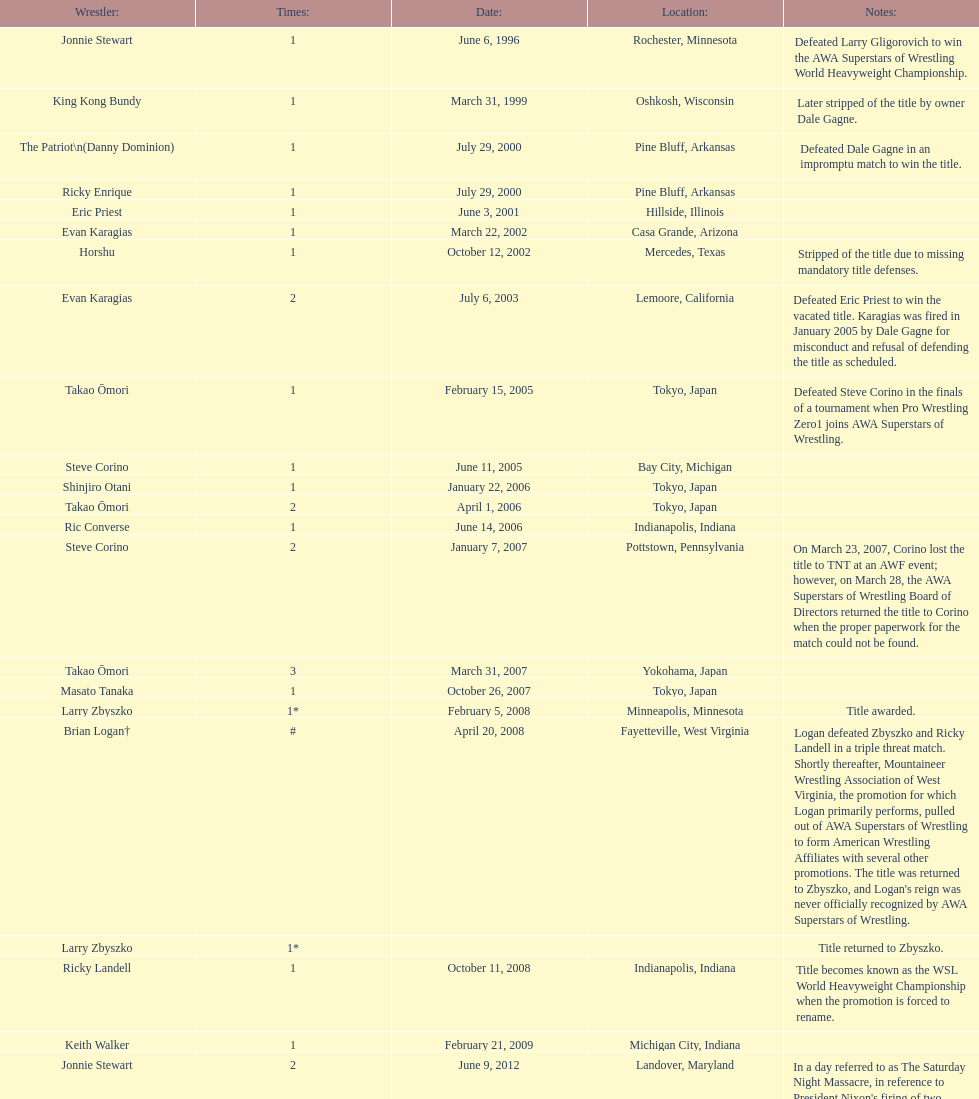Who is listed before keith walker? Ricky Landell. 